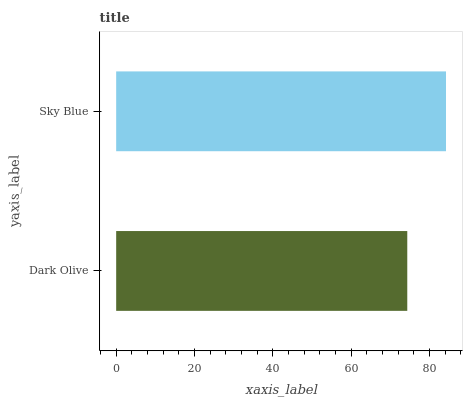Is Dark Olive the minimum?
Answer yes or no. Yes. Is Sky Blue the maximum?
Answer yes or no. Yes. Is Sky Blue the minimum?
Answer yes or no. No. Is Sky Blue greater than Dark Olive?
Answer yes or no. Yes. Is Dark Olive less than Sky Blue?
Answer yes or no. Yes. Is Dark Olive greater than Sky Blue?
Answer yes or no. No. Is Sky Blue less than Dark Olive?
Answer yes or no. No. Is Sky Blue the high median?
Answer yes or no. Yes. Is Dark Olive the low median?
Answer yes or no. Yes. Is Dark Olive the high median?
Answer yes or no. No. Is Sky Blue the low median?
Answer yes or no. No. 